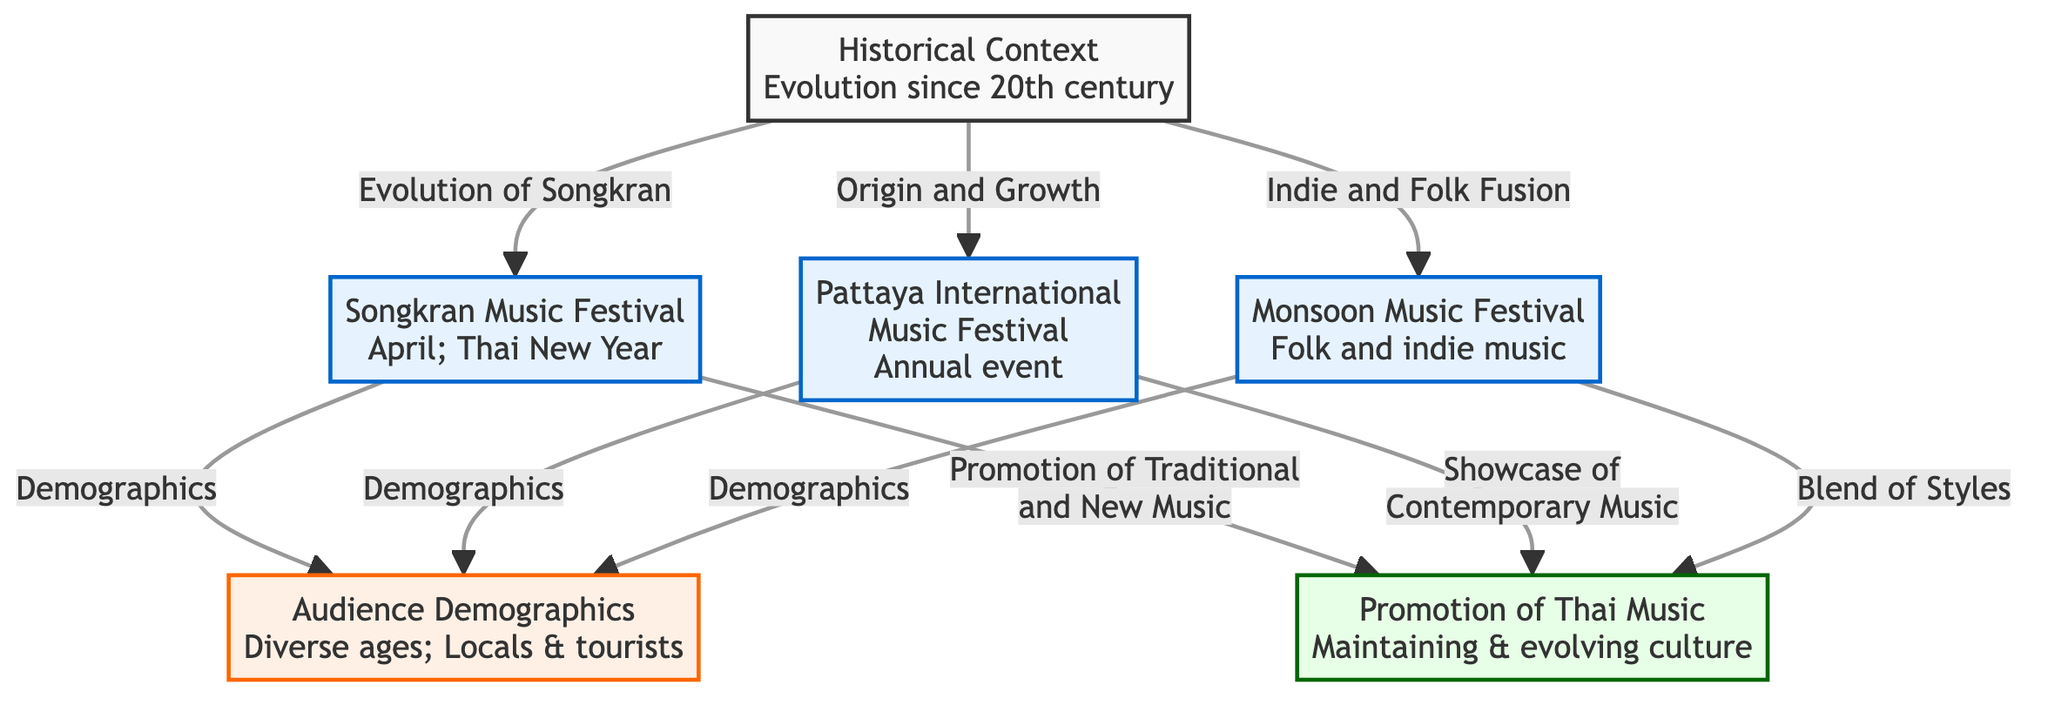What are the three main music festivals depicted in the diagram? The diagram lists five nodes that represent different music festivals. The ones highlighted under the festival category include the Songkran Music Festival, Pattaya International Music Festival, and Monsoon Music Festival.
Answer: Songkran Music Festival, Pattaya International Music Festival, Monsoon Music Festival What is the focus of the Monsoon Music Festival? The Monsoon Music Festival, represented in the diagram, is specifically linked to folk and indie music. This is stated directly in the label of the node for this festival.
Answer: Folk and indie music How many audience demographic characteristics are indicated in the diagram? The demographic section of the diagram shows a single node that mentions 'Diverse ages; Locals & tourists', which encompasses various audience characteristics. Therefore, there is one key demographic aspect identified in the diagram.
Answer: One Which music festival evolved from the Songkran historical context? The Songkran Music Festival is connected through the historical context node indicating its evolution since the 20th century. This suggests that it is a festival that has developed from its earlier traditions to the present.
Answer: Songkran Music Festival How do the festivals promote Thai music? The diagram illustrates that each festival has a specific role in the promotion of Thai music. The Songkran Music Festival promotes traditional and new music, the Pattaya International Music Festival showcases contemporary music, and the Monsoon Music Festival blends different styles. This interaction shows how festivals contribute to the music culture in Thailand.
Answer: By promoting traditional and new music, showcasing contemporary music, blending styles What relationship does the Pattaya International Music Festival have with audience demographics? The diagram clearly shows a direct relationship between the Pattaya International Music Festival and audience demographics. Each festival, including Pattaya, connects to the demographic node, indicating that it attracts a diverse audience consisting of both locals and tourists.
Answer: Demographics How does the diagram categorize the promoting aspects of Thai music? In the diagram, activities promoting Thai music are categorized under one node specifically labeled 'Promotion of Thai Music.' This encompasses the roles outlined for the three different festivals, emphasizing the overall significance of these cultural events.
Answer: Promotion of Thai Music What is the historical context of the music festivals in Thailand? The historical context node in the diagram indicates that Thai music festivals have evolved since the 20th century, giving insight into their longstanding tradition and development over time.
Answer: Evolution since 20th century 